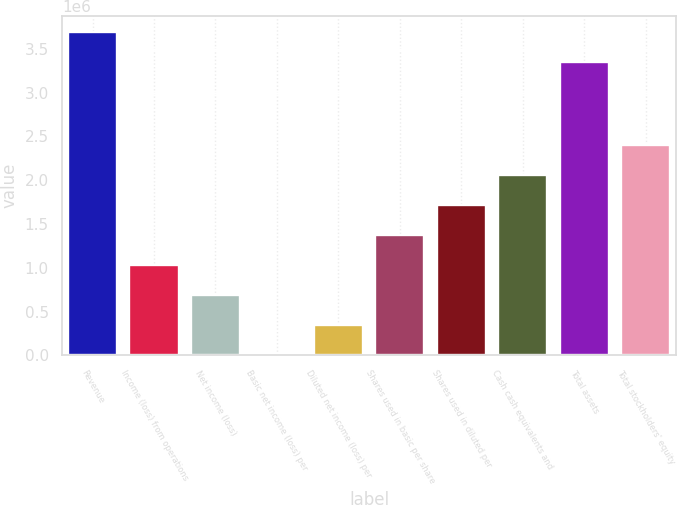Convert chart. <chart><loc_0><loc_0><loc_500><loc_500><bar_chart><fcel>Revenue<fcel>Income (loss) from operations<fcel>Net income (loss)<fcel>Basic net income (loss) per<fcel>Diluted net income (loss) per<fcel>Shares used in basic per share<fcel>Shares used in diluted per<fcel>Cash cash equivalents and<fcel>Total assets<fcel>Total stockholders' equity<nl><fcel>3.69321e+06<fcel>1.02746e+06<fcel>684972<fcel>0.05<fcel>342486<fcel>1.36994e+06<fcel>1.71243e+06<fcel>2.05492e+06<fcel>3.35073e+06<fcel>2.3974e+06<nl></chart> 